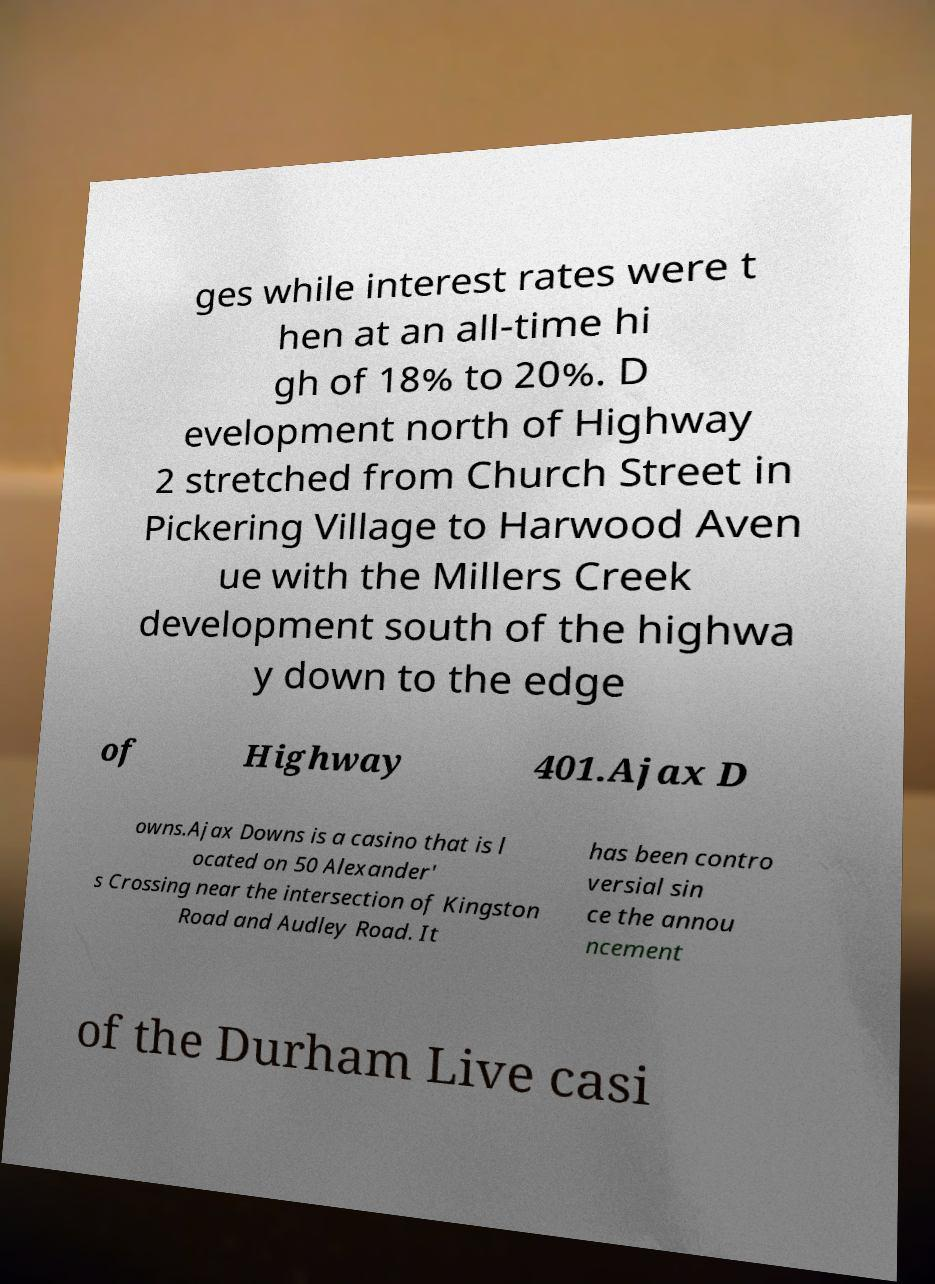There's text embedded in this image that I need extracted. Can you transcribe it verbatim? ges while interest rates were t hen at an all-time hi gh of 18% to 20%. D evelopment north of Highway 2 stretched from Church Street in Pickering Village to Harwood Aven ue with the Millers Creek development south of the highwa y down to the edge of Highway 401.Ajax D owns.Ajax Downs is a casino that is l ocated on 50 Alexander' s Crossing near the intersection of Kingston Road and Audley Road. It has been contro versial sin ce the annou ncement of the Durham Live casi 